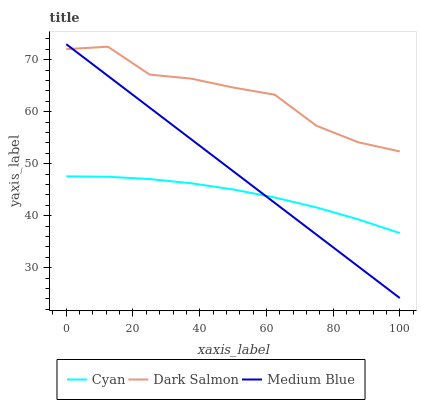Does Cyan have the minimum area under the curve?
Answer yes or no. Yes. Does Dark Salmon have the maximum area under the curve?
Answer yes or no. Yes. Does Medium Blue have the minimum area under the curve?
Answer yes or no. No. Does Medium Blue have the maximum area under the curve?
Answer yes or no. No. Is Medium Blue the smoothest?
Answer yes or no. Yes. Is Dark Salmon the roughest?
Answer yes or no. Yes. Is Dark Salmon the smoothest?
Answer yes or no. No. Is Medium Blue the roughest?
Answer yes or no. No. Does Medium Blue have the lowest value?
Answer yes or no. Yes. Does Dark Salmon have the lowest value?
Answer yes or no. No. Does Medium Blue have the highest value?
Answer yes or no. Yes. Does Dark Salmon have the highest value?
Answer yes or no. No. Is Cyan less than Dark Salmon?
Answer yes or no. Yes. Is Dark Salmon greater than Cyan?
Answer yes or no. Yes. Does Medium Blue intersect Dark Salmon?
Answer yes or no. Yes. Is Medium Blue less than Dark Salmon?
Answer yes or no. No. Is Medium Blue greater than Dark Salmon?
Answer yes or no. No. Does Cyan intersect Dark Salmon?
Answer yes or no. No. 